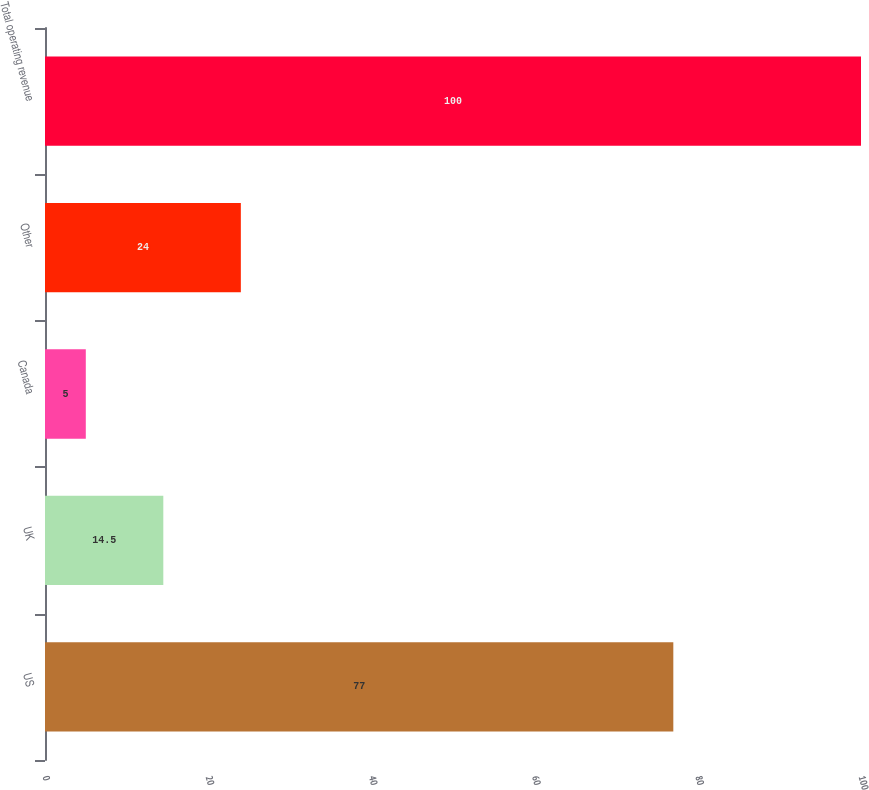Convert chart. <chart><loc_0><loc_0><loc_500><loc_500><bar_chart><fcel>US<fcel>UK<fcel>Canada<fcel>Other<fcel>Total operating revenue<nl><fcel>77<fcel>14.5<fcel>5<fcel>24<fcel>100<nl></chart> 